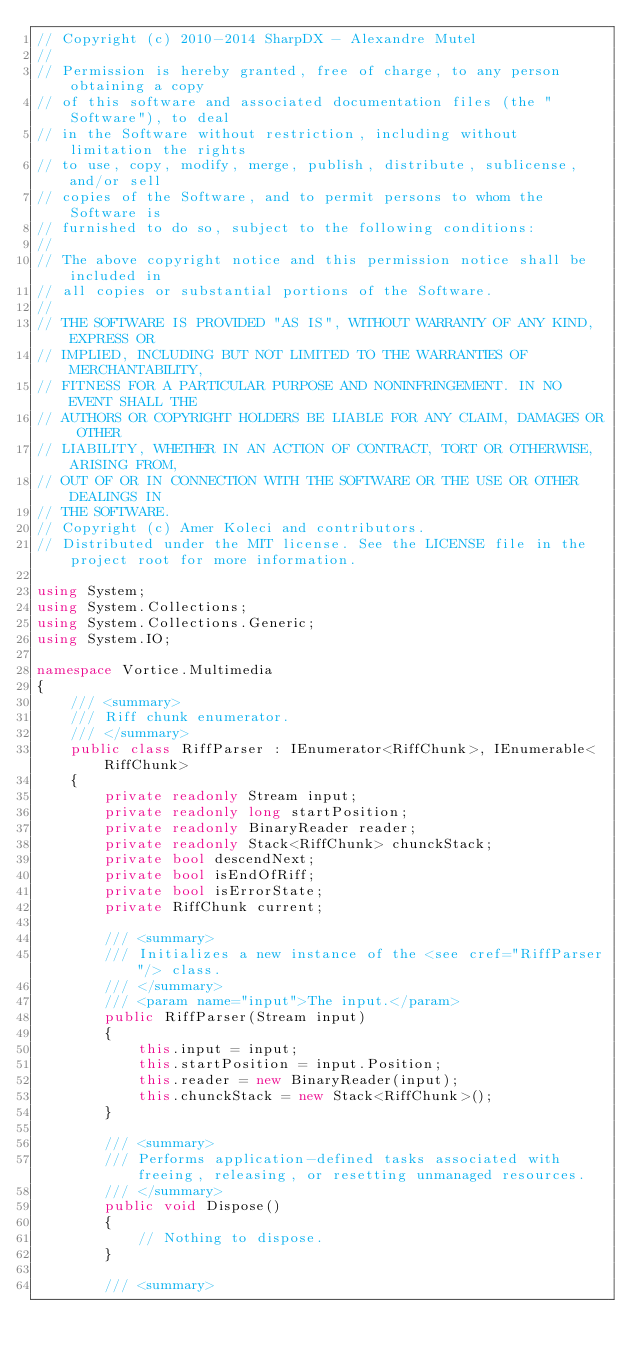<code> <loc_0><loc_0><loc_500><loc_500><_C#_>// Copyright (c) 2010-2014 SharpDX - Alexandre Mutel
// 
// Permission is hereby granted, free of charge, to any person obtaining a copy
// of this software and associated documentation files (the "Software"), to deal
// in the Software without restriction, including without limitation the rights
// to use, copy, modify, merge, publish, distribute, sublicense, and/or sell
// copies of the Software, and to permit persons to whom the Software is
// furnished to do so, subject to the following conditions:
// 
// The above copyright notice and this permission notice shall be included in
// all copies or substantial portions of the Software.
// 
// THE SOFTWARE IS PROVIDED "AS IS", WITHOUT WARRANTY OF ANY KIND, EXPRESS OR
// IMPLIED, INCLUDING BUT NOT LIMITED TO THE WARRANTIES OF MERCHANTABILITY,
// FITNESS FOR A PARTICULAR PURPOSE AND NONINFRINGEMENT. IN NO EVENT SHALL THE
// AUTHORS OR COPYRIGHT HOLDERS BE LIABLE FOR ANY CLAIM, DAMAGES OR OTHER
// LIABILITY, WHETHER IN AN ACTION OF CONTRACT, TORT OR OTHERWISE, ARISING FROM,
// OUT OF OR IN CONNECTION WITH THE SOFTWARE OR THE USE OR OTHER DEALINGS IN
// THE SOFTWARE.
// Copyright (c) Amer Koleci and contributors.
// Distributed under the MIT license. See the LICENSE file in the project root for more information.

using System;
using System.Collections;
using System.Collections.Generic;
using System.IO;

namespace Vortice.Multimedia
{
    /// <summary>
    /// Riff chunk enumerator.
    /// </summary>
    public class RiffParser : IEnumerator<RiffChunk>, IEnumerable<RiffChunk>
    {
        private readonly Stream input;
        private readonly long startPosition;
        private readonly BinaryReader reader;
        private readonly Stack<RiffChunk> chunckStack;
        private bool descendNext;
        private bool isEndOfRiff;
        private bool isErrorState;
        private RiffChunk current;

        /// <summary>
        /// Initializes a new instance of the <see cref="RiffParser"/> class.
        /// </summary>
        /// <param name="input">The input.</param>
        public RiffParser(Stream input)
        {
            this.input = input;
            this.startPosition = input.Position;
            this.reader = new BinaryReader(input);
            this.chunckStack = new Stack<RiffChunk>();
        }

        /// <summary>
        /// Performs application-defined tasks associated with freeing, releasing, or resetting unmanaged resources.
        /// </summary>
        public void Dispose()
        {
            // Nothing to dispose.
        }

        /// <summary></code> 